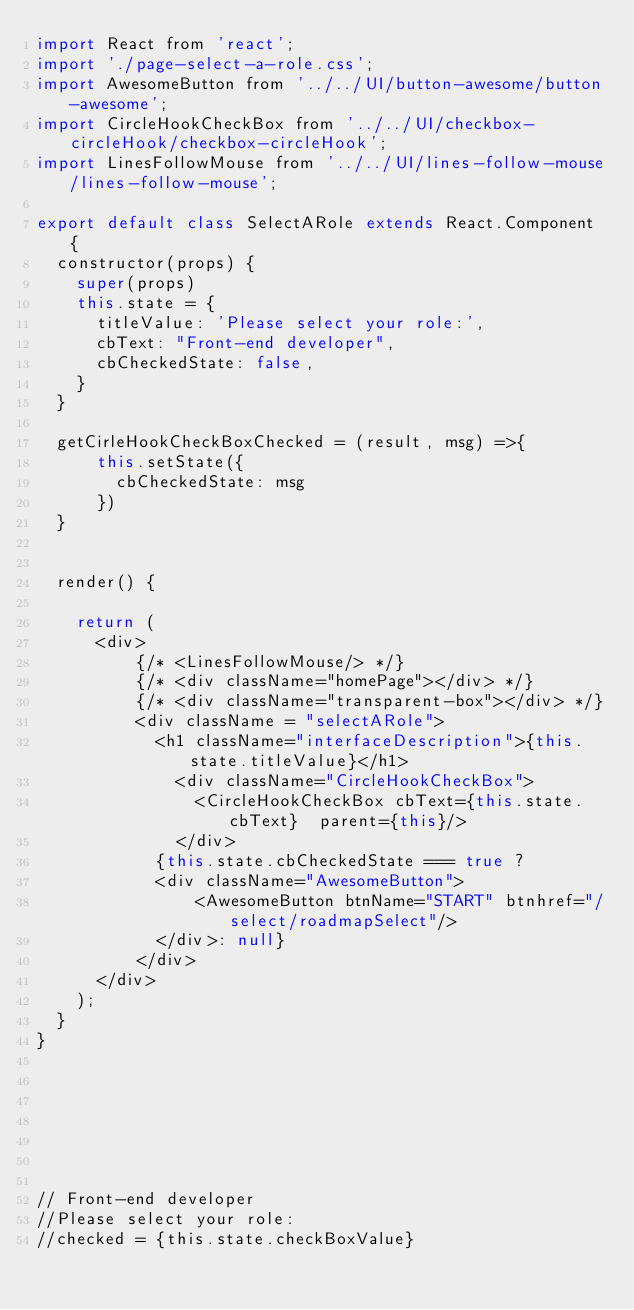<code> <loc_0><loc_0><loc_500><loc_500><_JavaScript_>import React from 'react';
import './page-select-a-role.css';
import AwesomeButton from '../../UI/button-awesome/button-awesome';
import CircleHookCheckBox from '../../UI/checkbox-circleHook/checkbox-circleHook';
import LinesFollowMouse from '../../UI/lines-follow-mouse/lines-follow-mouse';

export default class SelectARole extends React.Component {
  constructor(props) {
  	super(props)
    this.state = {
      titleValue: 'Please select your role:',
      cbText: "Front-end developer",
      cbCheckedState: false,
    }
  }
  
  getCirleHookCheckBoxChecked = (result, msg) =>{
      this.setState({
        cbCheckedState: msg
      })
  }


  render() {

    return (
      <div>
          {/* <LinesFollowMouse/> */}
          {/* <div className="homePage"></div> */}
          {/* <div className="transparent-box"></div> */}
          <div className = "selectARole">
            <h1 className="interfaceDescription">{this.state.titleValue}</h1>
              <div className="CircleHookCheckBox">
                <CircleHookCheckBox cbText={this.state.cbText}  parent={this}/>
              </div>
            {this.state.cbCheckedState === true ? 
            <div className="AwesomeButton">
                <AwesomeButton btnName="START" btnhref="/select/roadmapSelect"/> 
            </div>: null} 
          </div>
      </div>
    );
  }
}







// Front-end developer  
//Please select your role:
//checked = {this.state.checkBoxValue} </code> 